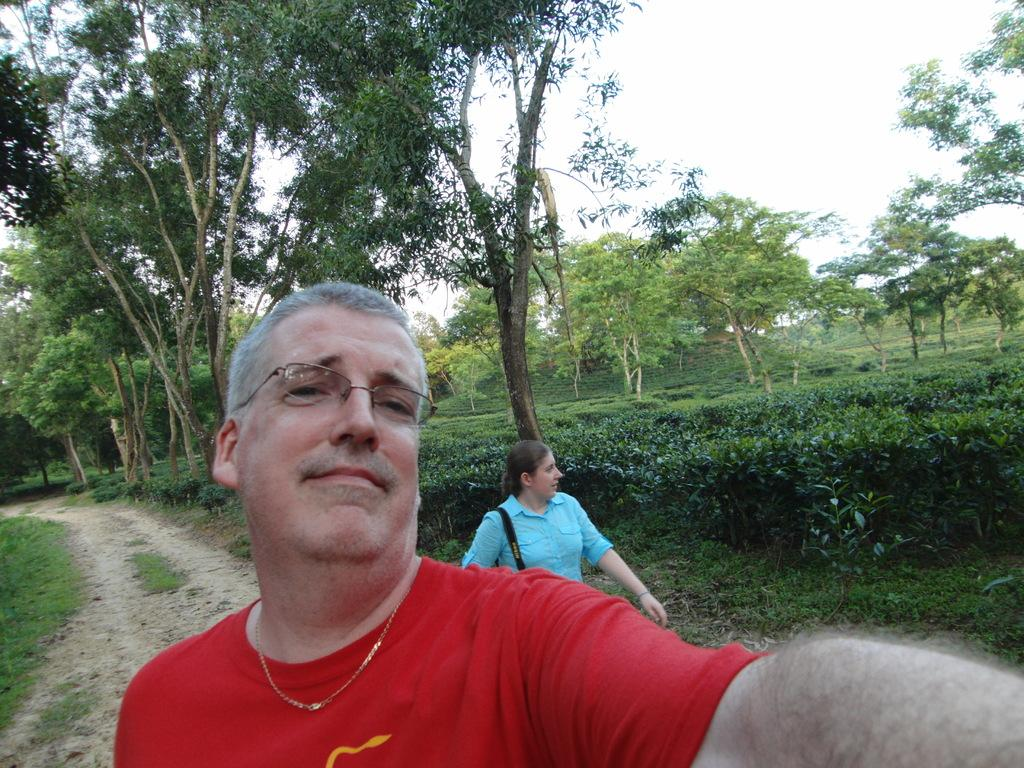What is the person in the center of the image wearing? The person in the center of the image is wearing a red color t-shirt. Can you describe the lady behind the person? The lady behind the person is wearing a blue color shirt. What can be seen in the background of the image? There are trees in the background of the image. Are there any icicles hanging from the trees in the image? There is no mention of icicles in the provided facts, and therefore we cannot determine if there are any in the image. 